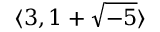<formula> <loc_0><loc_0><loc_500><loc_500>\langle 3 , 1 + { \sqrt { - 5 } } \rangle</formula> 